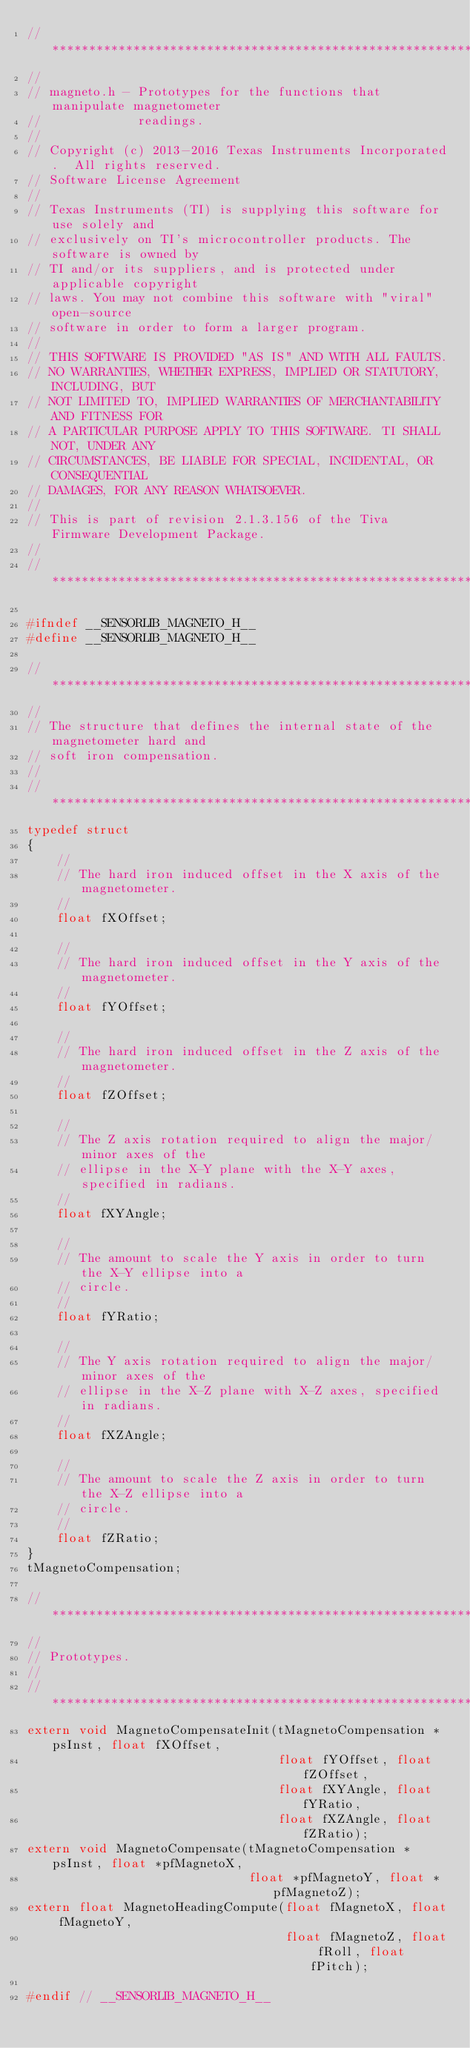<code> <loc_0><loc_0><loc_500><loc_500><_C_>//*****************************************************************************
//
// magneto.h - Prototypes for the functions that manipulate magnetometer
//             readings.
//
// Copyright (c) 2013-2016 Texas Instruments Incorporated.  All rights reserved.
// Software License Agreement
// 
// Texas Instruments (TI) is supplying this software for use solely and
// exclusively on TI's microcontroller products. The software is owned by
// TI and/or its suppliers, and is protected under applicable copyright
// laws. You may not combine this software with "viral" open-source
// software in order to form a larger program.
// 
// THIS SOFTWARE IS PROVIDED "AS IS" AND WITH ALL FAULTS.
// NO WARRANTIES, WHETHER EXPRESS, IMPLIED OR STATUTORY, INCLUDING, BUT
// NOT LIMITED TO, IMPLIED WARRANTIES OF MERCHANTABILITY AND FITNESS FOR
// A PARTICULAR PURPOSE APPLY TO THIS SOFTWARE. TI SHALL NOT, UNDER ANY
// CIRCUMSTANCES, BE LIABLE FOR SPECIAL, INCIDENTAL, OR CONSEQUENTIAL
// DAMAGES, FOR ANY REASON WHATSOEVER.
// 
// This is part of revision 2.1.3.156 of the Tiva Firmware Development Package.
//
//*****************************************************************************

#ifndef __SENSORLIB_MAGNETO_H__
#define __SENSORLIB_MAGNETO_H__

//*****************************************************************************
//
// The structure that defines the internal state of the magnetometer hard and
// soft iron compensation.
//
//*****************************************************************************
typedef struct
{
    //
    // The hard iron induced offset in the X axis of the magnetometer.
    //
    float fXOffset;

    //
    // The hard iron induced offset in the Y axis of the magnetometer.
    //
    float fYOffset;

    //
    // The hard iron induced offset in the Z axis of the magnetometer.
    //
    float fZOffset;

    //
    // The Z axis rotation required to align the major/minor axes of the
    // ellipse in the X-Y plane with the X-Y axes, specified in radians.
    //
    float fXYAngle;

    //
    // The amount to scale the Y axis in order to turn the X-Y ellipse into a
    // circle.
    //
    float fYRatio;

    //
    // The Y axis rotation required to align the major/minor axes of the
    // ellipse in the X-Z plane with X-Z axes, specified in radians.
    //
    float fXZAngle;

    //
    // The amount to scale the Z axis in order to turn the X-Z ellipse into a
    // circle.
    //
    float fZRatio;
}
tMagnetoCompensation;

//*****************************************************************************
//
// Prototypes.
//
//*****************************************************************************
extern void MagnetoCompensateInit(tMagnetoCompensation *psInst, float fXOffset,
                                  float fYOffset, float fZOffset,
                                  float fXYAngle, float fYRatio,
                                  float fXZAngle, float fZRatio);
extern void MagnetoCompensate(tMagnetoCompensation *psInst, float *pfMagnetoX,
                              float *pfMagnetoY, float *pfMagnetoZ);
extern float MagnetoHeadingCompute(float fMagnetoX, float fMagnetoY,
                                   float fMagnetoZ, float fRoll, float fPitch);

#endif // __SENSORLIB_MAGNETO_H__
</code> 